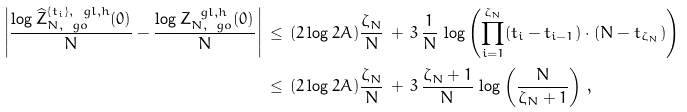<formula> <loc_0><loc_0><loc_500><loc_500>\left | \frac { \log \widehat { Z } _ { N , \ g o } ^ { \{ t _ { i } \} , \ g l , h } ( 0 ) } { N } - \frac { \log Z _ { N , \ g o } ^ { \ g l , h } ( 0 ) } { N } \right | & \, \leq \, ( 2 \log 2 A ) \frac { \zeta _ { N } } { N } \, + \, 3 \, \frac { 1 } { N } \, \log \left ( \prod _ { i = 1 } ^ { \zeta _ { N } } ( t _ { i } - t _ { i - 1 } ) \cdot ( N - t _ { \zeta _ { N } } ) \right ) \\ & \, \leq \, ( 2 \log 2 A ) \frac { \zeta _ { N } } { N } \, + \, 3 \, \frac { \zeta _ { N } + 1 } { N } \, \log \left ( \frac { N } { \zeta _ { N } + 1 } \right ) \, ,</formula> 